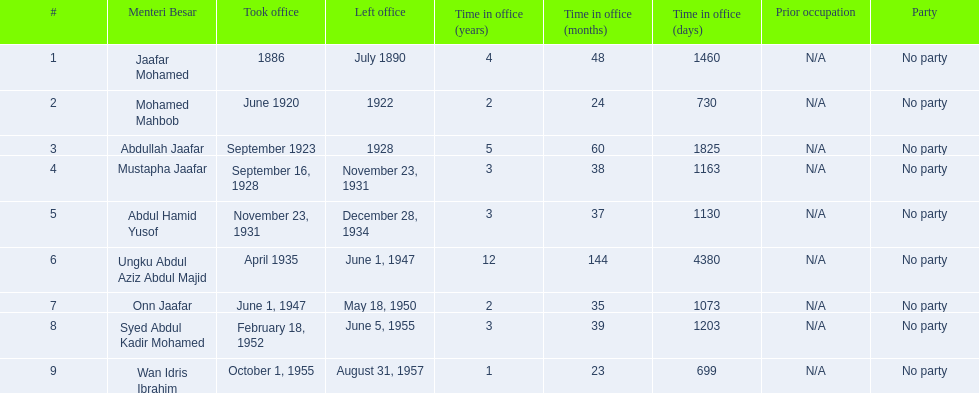Help me parse the entirety of this table. {'header': ['#', 'Menteri Besar', 'Took office', 'Left office', 'Time in office (years)', 'Time in office (months)', 'Time in office (days)', 'Prior occupation', 'Party'], 'rows': [['1', 'Jaafar Mohamed', '1886', 'July 1890', '4', '48', '1460', 'N/A', 'No party'], ['2', 'Mohamed Mahbob', 'June 1920', '1922', '2', '24', '730', 'N/A', 'No party'], ['3', 'Abdullah Jaafar', 'September 1923', '1928', '5', '60', '1825', 'N/A', 'No party'], ['4', 'Mustapha Jaafar', 'September 16, 1928', 'November 23, 1931', '3', '38', '1163', 'N/A', 'No party'], ['5', 'Abdul Hamid Yusof', 'November 23, 1931', 'December 28, 1934', '3', '37', '1130', 'N/A', 'No party'], ['6', 'Ungku Abdul Aziz Abdul Majid', 'April 1935', 'June 1, 1947', '12', '144', '4380', 'N/A', 'No party'], ['7', 'Onn Jaafar', 'June 1, 1947', 'May 18, 1950', '2', '35', '1073', 'N/A', 'No party'], ['8', 'Syed Abdul Kadir Mohamed', 'February 18, 1952', 'June 5, 1955', '3', '39', '1203', 'N/A', 'No party'], ['9', 'Wan Idris Ibrahim', 'October 1, 1955', 'August 31, 1957', '1', '23', '699', 'N/A', 'No party']]} How many years was jaafar mohamed in office? 4. 